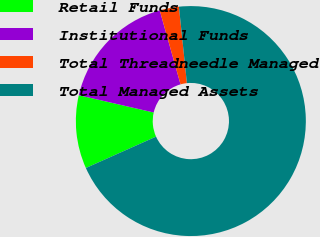Convert chart. <chart><loc_0><loc_0><loc_500><loc_500><pie_chart><fcel>Retail Funds<fcel>Institutional Funds<fcel>Total Threadneedle Managed<fcel>Total Managed Assets<nl><fcel>10.3%<fcel>17.03%<fcel>2.71%<fcel>69.96%<nl></chart> 